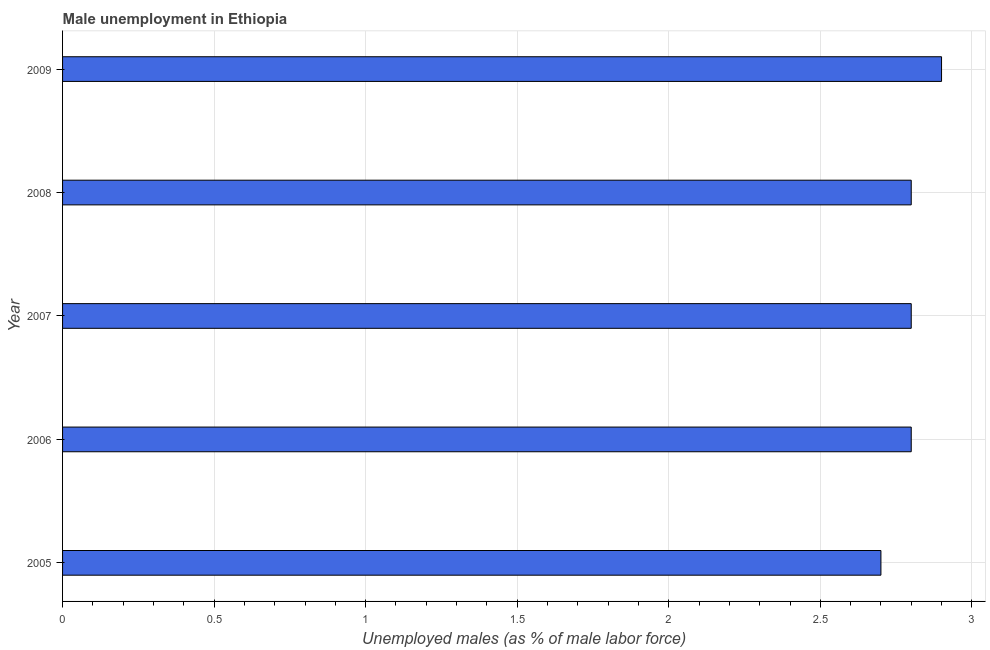Does the graph contain grids?
Keep it short and to the point. Yes. What is the title of the graph?
Provide a succinct answer. Male unemployment in Ethiopia. What is the label or title of the X-axis?
Your answer should be compact. Unemployed males (as % of male labor force). What is the unemployed males population in 2007?
Provide a short and direct response. 2.8. Across all years, what is the maximum unemployed males population?
Make the answer very short. 2.9. Across all years, what is the minimum unemployed males population?
Ensure brevity in your answer.  2.7. In which year was the unemployed males population minimum?
Make the answer very short. 2005. What is the sum of the unemployed males population?
Your answer should be very brief. 14. What is the difference between the unemployed males population in 2007 and 2008?
Provide a succinct answer. 0. What is the average unemployed males population per year?
Offer a very short reply. 2.8. What is the median unemployed males population?
Offer a terse response. 2.8. In how many years, is the unemployed males population greater than 2.6 %?
Give a very brief answer. 5. Is the unemployed males population in 2006 less than that in 2008?
Offer a very short reply. No. What is the difference between the highest and the second highest unemployed males population?
Provide a succinct answer. 0.1. In how many years, is the unemployed males population greater than the average unemployed males population taken over all years?
Your answer should be very brief. 1. How many bars are there?
Your response must be concise. 5. Are the values on the major ticks of X-axis written in scientific E-notation?
Your answer should be very brief. No. What is the Unemployed males (as % of male labor force) of 2005?
Your answer should be very brief. 2.7. What is the Unemployed males (as % of male labor force) in 2006?
Offer a very short reply. 2.8. What is the Unemployed males (as % of male labor force) in 2007?
Your answer should be very brief. 2.8. What is the Unemployed males (as % of male labor force) of 2008?
Make the answer very short. 2.8. What is the Unemployed males (as % of male labor force) of 2009?
Provide a succinct answer. 2.9. What is the difference between the Unemployed males (as % of male labor force) in 2005 and 2006?
Provide a short and direct response. -0.1. What is the difference between the Unemployed males (as % of male labor force) in 2005 and 2008?
Ensure brevity in your answer.  -0.1. What is the difference between the Unemployed males (as % of male labor force) in 2006 and 2008?
Offer a very short reply. 0. What is the difference between the Unemployed males (as % of male labor force) in 2006 and 2009?
Ensure brevity in your answer.  -0.1. What is the difference between the Unemployed males (as % of male labor force) in 2007 and 2009?
Give a very brief answer. -0.1. What is the ratio of the Unemployed males (as % of male labor force) in 2005 to that in 2006?
Provide a short and direct response. 0.96. What is the ratio of the Unemployed males (as % of male labor force) in 2005 to that in 2008?
Offer a very short reply. 0.96. What is the ratio of the Unemployed males (as % of male labor force) in 2006 to that in 2007?
Provide a succinct answer. 1. What is the ratio of the Unemployed males (as % of male labor force) in 2006 to that in 2009?
Offer a very short reply. 0.97. What is the ratio of the Unemployed males (as % of male labor force) in 2007 to that in 2008?
Offer a terse response. 1. 